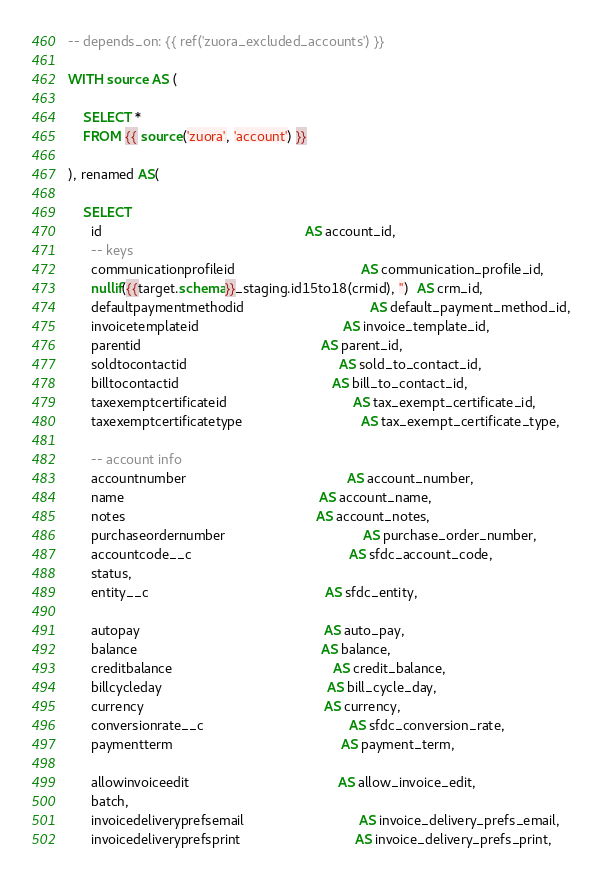<code> <loc_0><loc_0><loc_500><loc_500><_SQL_>-- depends_on: {{ ref('zuora_excluded_accounts') }}

WITH source AS (

    SELECT *
    FROM {{ source('zuora', 'account') }}

), renamed AS(

    SELECT
      id                                                     AS account_id,
      -- keys
      communicationprofileid                                 AS communication_profile_id,
      nullif({{target.schema}}_staging.id15to18(crmid), '')  AS crm_id,
      defaultpaymentmethodid                                 AS default_payment_method_id,
      invoicetemplateid                                      AS invoice_template_id,
      parentid                                               AS parent_id,
      soldtocontactid                                        AS sold_to_contact_id,
      billtocontactid                                        AS bill_to_contact_id,
      taxexemptcertificateid                                 AS tax_exempt_certificate_id,
      taxexemptcertificatetype                               AS tax_exempt_certificate_type,

      -- account info
      accountnumber                                          AS account_number,
      name                                                   AS account_name,
      notes                                                  AS account_notes,
      purchaseordernumber                                    AS purchase_order_number,
      accountcode__c                                         AS sfdc_account_code,
      status,
      entity__c                                              AS sfdc_entity,

      autopay                                                AS auto_pay,
      balance                                                AS balance,
      creditbalance                                          AS credit_balance,
      billcycleday                                           AS bill_cycle_day,
      currency                                               AS currency,
      conversionrate__c                                      AS sfdc_conversion_rate,
      paymentterm                                            AS payment_term,

      allowinvoiceedit                                       AS allow_invoice_edit,
      batch,
      invoicedeliveryprefsemail                              AS invoice_delivery_prefs_email,
      invoicedeliveryprefsprint                              AS invoice_delivery_prefs_print,</code> 